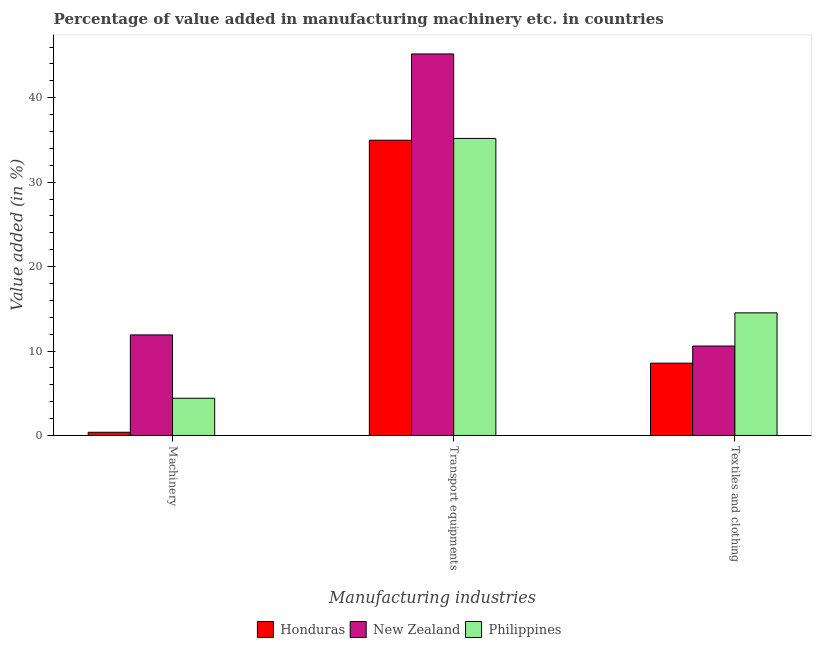How many different coloured bars are there?
Your answer should be compact. 3. Are the number of bars per tick equal to the number of legend labels?
Your answer should be compact. Yes. What is the label of the 1st group of bars from the left?
Provide a succinct answer. Machinery. What is the value added in manufacturing transport equipments in Honduras?
Offer a very short reply. 34.97. Across all countries, what is the maximum value added in manufacturing machinery?
Your answer should be very brief. 11.91. Across all countries, what is the minimum value added in manufacturing machinery?
Make the answer very short. 0.38. In which country was the value added in manufacturing transport equipments maximum?
Keep it short and to the point. New Zealand. In which country was the value added in manufacturing machinery minimum?
Your answer should be compact. Honduras. What is the total value added in manufacturing machinery in the graph?
Provide a short and direct response. 16.69. What is the difference between the value added in manufacturing textile and clothing in Honduras and that in Philippines?
Give a very brief answer. -5.96. What is the difference between the value added in manufacturing textile and clothing in New Zealand and the value added in manufacturing transport equipments in Philippines?
Offer a terse response. -24.59. What is the average value added in manufacturing textile and clothing per country?
Provide a succinct answer. 11.22. What is the difference between the value added in manufacturing machinery and value added in manufacturing transport equipments in New Zealand?
Make the answer very short. -33.28. What is the ratio of the value added in manufacturing textile and clothing in Philippines to that in Honduras?
Provide a short and direct response. 1.7. What is the difference between the highest and the second highest value added in manufacturing machinery?
Give a very brief answer. 7.5. What is the difference between the highest and the lowest value added in manufacturing machinery?
Keep it short and to the point. 11.53. In how many countries, is the value added in manufacturing transport equipments greater than the average value added in manufacturing transport equipments taken over all countries?
Provide a short and direct response. 1. What does the 2nd bar from the right in Transport equipments represents?
Your answer should be very brief. New Zealand. Is it the case that in every country, the sum of the value added in manufacturing machinery and value added in manufacturing transport equipments is greater than the value added in manufacturing textile and clothing?
Keep it short and to the point. Yes. How many bars are there?
Your answer should be compact. 9. Are all the bars in the graph horizontal?
Your answer should be compact. No. How many countries are there in the graph?
Your answer should be compact. 3. What is the difference between two consecutive major ticks on the Y-axis?
Offer a terse response. 10. Does the graph contain any zero values?
Your answer should be compact. No. Does the graph contain grids?
Give a very brief answer. No. How are the legend labels stacked?
Offer a very short reply. Horizontal. What is the title of the graph?
Keep it short and to the point. Percentage of value added in manufacturing machinery etc. in countries. Does "Guam" appear as one of the legend labels in the graph?
Ensure brevity in your answer.  No. What is the label or title of the X-axis?
Provide a succinct answer. Manufacturing industries. What is the label or title of the Y-axis?
Provide a short and direct response. Value added (in %). What is the Value added (in %) of Honduras in Machinery?
Your answer should be very brief. 0.38. What is the Value added (in %) in New Zealand in Machinery?
Ensure brevity in your answer.  11.91. What is the Value added (in %) of Philippines in Machinery?
Make the answer very short. 4.4. What is the Value added (in %) in Honduras in Transport equipments?
Keep it short and to the point. 34.97. What is the Value added (in %) of New Zealand in Transport equipments?
Your response must be concise. 45.19. What is the Value added (in %) in Philippines in Transport equipments?
Your answer should be very brief. 35.18. What is the Value added (in %) in Honduras in Textiles and clothing?
Provide a short and direct response. 8.56. What is the Value added (in %) of New Zealand in Textiles and clothing?
Ensure brevity in your answer.  10.59. What is the Value added (in %) in Philippines in Textiles and clothing?
Ensure brevity in your answer.  14.52. Across all Manufacturing industries, what is the maximum Value added (in %) of Honduras?
Give a very brief answer. 34.97. Across all Manufacturing industries, what is the maximum Value added (in %) of New Zealand?
Provide a succinct answer. 45.19. Across all Manufacturing industries, what is the maximum Value added (in %) of Philippines?
Your answer should be very brief. 35.18. Across all Manufacturing industries, what is the minimum Value added (in %) of Honduras?
Your answer should be compact. 0.38. Across all Manufacturing industries, what is the minimum Value added (in %) of New Zealand?
Your response must be concise. 10.59. Across all Manufacturing industries, what is the minimum Value added (in %) in Philippines?
Offer a terse response. 4.4. What is the total Value added (in %) of Honduras in the graph?
Make the answer very short. 43.91. What is the total Value added (in %) in New Zealand in the graph?
Your answer should be compact. 67.68. What is the total Value added (in %) in Philippines in the graph?
Offer a terse response. 54.1. What is the difference between the Value added (in %) of Honduras in Machinery and that in Transport equipments?
Offer a very short reply. -34.59. What is the difference between the Value added (in %) in New Zealand in Machinery and that in Transport equipments?
Offer a terse response. -33.28. What is the difference between the Value added (in %) in Philippines in Machinery and that in Transport equipments?
Your response must be concise. -30.77. What is the difference between the Value added (in %) in Honduras in Machinery and that in Textiles and clothing?
Make the answer very short. -8.18. What is the difference between the Value added (in %) in New Zealand in Machinery and that in Textiles and clothing?
Ensure brevity in your answer.  1.32. What is the difference between the Value added (in %) of Philippines in Machinery and that in Textiles and clothing?
Your answer should be very brief. -10.12. What is the difference between the Value added (in %) of Honduras in Transport equipments and that in Textiles and clothing?
Make the answer very short. 26.41. What is the difference between the Value added (in %) of New Zealand in Transport equipments and that in Textiles and clothing?
Give a very brief answer. 34.6. What is the difference between the Value added (in %) in Philippines in Transport equipments and that in Textiles and clothing?
Offer a terse response. 20.66. What is the difference between the Value added (in %) of Honduras in Machinery and the Value added (in %) of New Zealand in Transport equipments?
Make the answer very short. -44.81. What is the difference between the Value added (in %) in Honduras in Machinery and the Value added (in %) in Philippines in Transport equipments?
Provide a short and direct response. -34.8. What is the difference between the Value added (in %) of New Zealand in Machinery and the Value added (in %) of Philippines in Transport equipments?
Offer a terse response. -23.27. What is the difference between the Value added (in %) in Honduras in Machinery and the Value added (in %) in New Zealand in Textiles and clothing?
Provide a short and direct response. -10.21. What is the difference between the Value added (in %) of Honduras in Machinery and the Value added (in %) of Philippines in Textiles and clothing?
Give a very brief answer. -14.14. What is the difference between the Value added (in %) in New Zealand in Machinery and the Value added (in %) in Philippines in Textiles and clothing?
Offer a very short reply. -2.61. What is the difference between the Value added (in %) in Honduras in Transport equipments and the Value added (in %) in New Zealand in Textiles and clothing?
Offer a terse response. 24.38. What is the difference between the Value added (in %) of Honduras in Transport equipments and the Value added (in %) of Philippines in Textiles and clothing?
Provide a succinct answer. 20.45. What is the difference between the Value added (in %) in New Zealand in Transport equipments and the Value added (in %) in Philippines in Textiles and clothing?
Ensure brevity in your answer.  30.67. What is the average Value added (in %) of Honduras per Manufacturing industries?
Your answer should be very brief. 14.64. What is the average Value added (in %) in New Zealand per Manufacturing industries?
Offer a terse response. 22.56. What is the average Value added (in %) of Philippines per Manufacturing industries?
Your answer should be very brief. 18.03. What is the difference between the Value added (in %) in Honduras and Value added (in %) in New Zealand in Machinery?
Provide a short and direct response. -11.53. What is the difference between the Value added (in %) of Honduras and Value added (in %) of Philippines in Machinery?
Provide a short and direct response. -4.03. What is the difference between the Value added (in %) of New Zealand and Value added (in %) of Philippines in Machinery?
Offer a very short reply. 7.5. What is the difference between the Value added (in %) in Honduras and Value added (in %) in New Zealand in Transport equipments?
Give a very brief answer. -10.22. What is the difference between the Value added (in %) in Honduras and Value added (in %) in Philippines in Transport equipments?
Keep it short and to the point. -0.21. What is the difference between the Value added (in %) in New Zealand and Value added (in %) in Philippines in Transport equipments?
Your answer should be compact. 10.01. What is the difference between the Value added (in %) of Honduras and Value added (in %) of New Zealand in Textiles and clothing?
Offer a terse response. -2.03. What is the difference between the Value added (in %) of Honduras and Value added (in %) of Philippines in Textiles and clothing?
Keep it short and to the point. -5.96. What is the difference between the Value added (in %) of New Zealand and Value added (in %) of Philippines in Textiles and clothing?
Ensure brevity in your answer.  -3.93. What is the ratio of the Value added (in %) of Honduras in Machinery to that in Transport equipments?
Your answer should be compact. 0.01. What is the ratio of the Value added (in %) of New Zealand in Machinery to that in Transport equipments?
Ensure brevity in your answer.  0.26. What is the ratio of the Value added (in %) in Philippines in Machinery to that in Transport equipments?
Your answer should be compact. 0.13. What is the ratio of the Value added (in %) of Honduras in Machinery to that in Textiles and clothing?
Offer a terse response. 0.04. What is the ratio of the Value added (in %) of New Zealand in Machinery to that in Textiles and clothing?
Make the answer very short. 1.12. What is the ratio of the Value added (in %) in Philippines in Machinery to that in Textiles and clothing?
Provide a succinct answer. 0.3. What is the ratio of the Value added (in %) of Honduras in Transport equipments to that in Textiles and clothing?
Provide a short and direct response. 4.08. What is the ratio of the Value added (in %) of New Zealand in Transport equipments to that in Textiles and clothing?
Your answer should be compact. 4.27. What is the ratio of the Value added (in %) of Philippines in Transport equipments to that in Textiles and clothing?
Provide a short and direct response. 2.42. What is the difference between the highest and the second highest Value added (in %) of Honduras?
Keep it short and to the point. 26.41. What is the difference between the highest and the second highest Value added (in %) of New Zealand?
Offer a terse response. 33.28. What is the difference between the highest and the second highest Value added (in %) of Philippines?
Offer a terse response. 20.66. What is the difference between the highest and the lowest Value added (in %) in Honduras?
Keep it short and to the point. 34.59. What is the difference between the highest and the lowest Value added (in %) of New Zealand?
Your response must be concise. 34.6. What is the difference between the highest and the lowest Value added (in %) of Philippines?
Give a very brief answer. 30.77. 